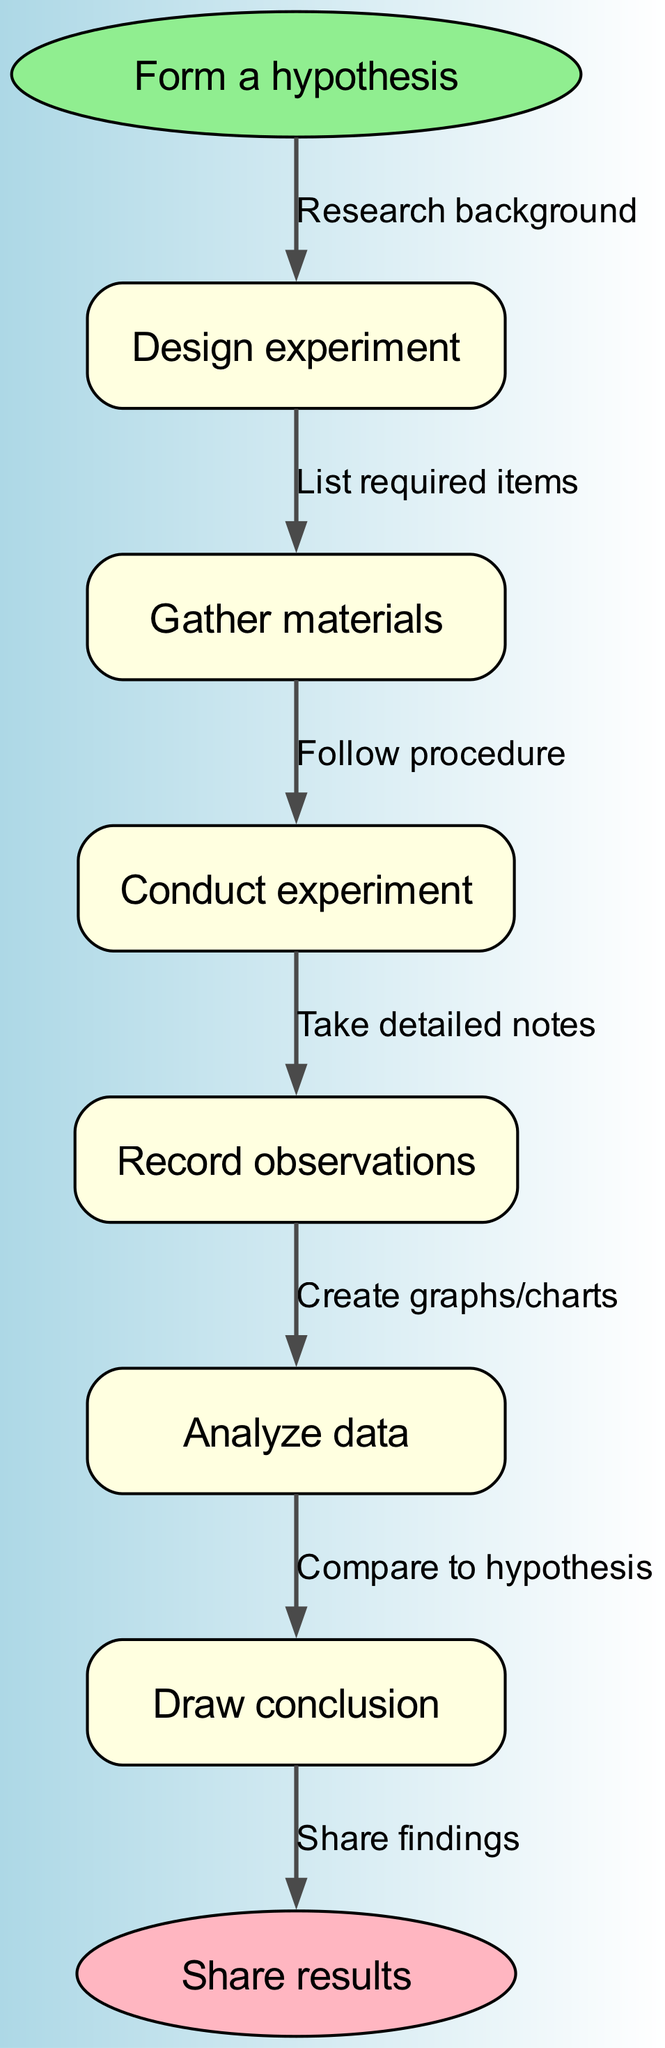What is the first step in the science experiment process? The diagram starts at the "Form a hypothesis" node, indicating that this is the first action taken in the science experiment process.
Answer: Form a hypothesis How many total nodes are there in the flow chart? There is one starting node, five intermediate nodes, and one ending node, making a total of seven nodes in the diagram (1 + 5 + 1 = 7).
Answer: Seven What is the final step indicated in the diagram? The end node is labeled "Share results," which signifies the last action in the science experiment process.
Answer: Share results What is the relationship between "Conduct experiment" and "Analyze data"? "Conduct experiment" is connected to "Analyze data" through the edge labeled "Follow procedure," showing the flow from conducting the experiment to analyzing the gathered data.
Answer: Follow procedure Which step comes immediately after "Record observations"? The node following "Record observations" is "Analyze data," which signifies the next step in the process of a science experiment.
Answer: Analyze data What does the edge labeled "List required items" lead to? The edge labeled "List required items" connects from the "Design experiment" node to the next node, indicating that this is an action taken to gather necessary resources.
Answer: Gather materials How does the flow of the diagram indicate progression in the experiment process? The flow chart progresses from one node to the next in a sequential manner, illustrating the logical order of conducting a science experiment, from hypothesis to conclusions.
Answer: Sequential manner What node is connected to "Gather materials"? "Gather materials" is connected to "Conduct experiment," showing the direct flow from gathering needed items to actually performing the experiment.
Answer: Conduct experiment What action follows the "Analyze data" step? The step immediately following "Analyze data" is "Draw conclusion," indicating that conclusions are drawn based on the analyzed data.
Answer: Draw conclusion 